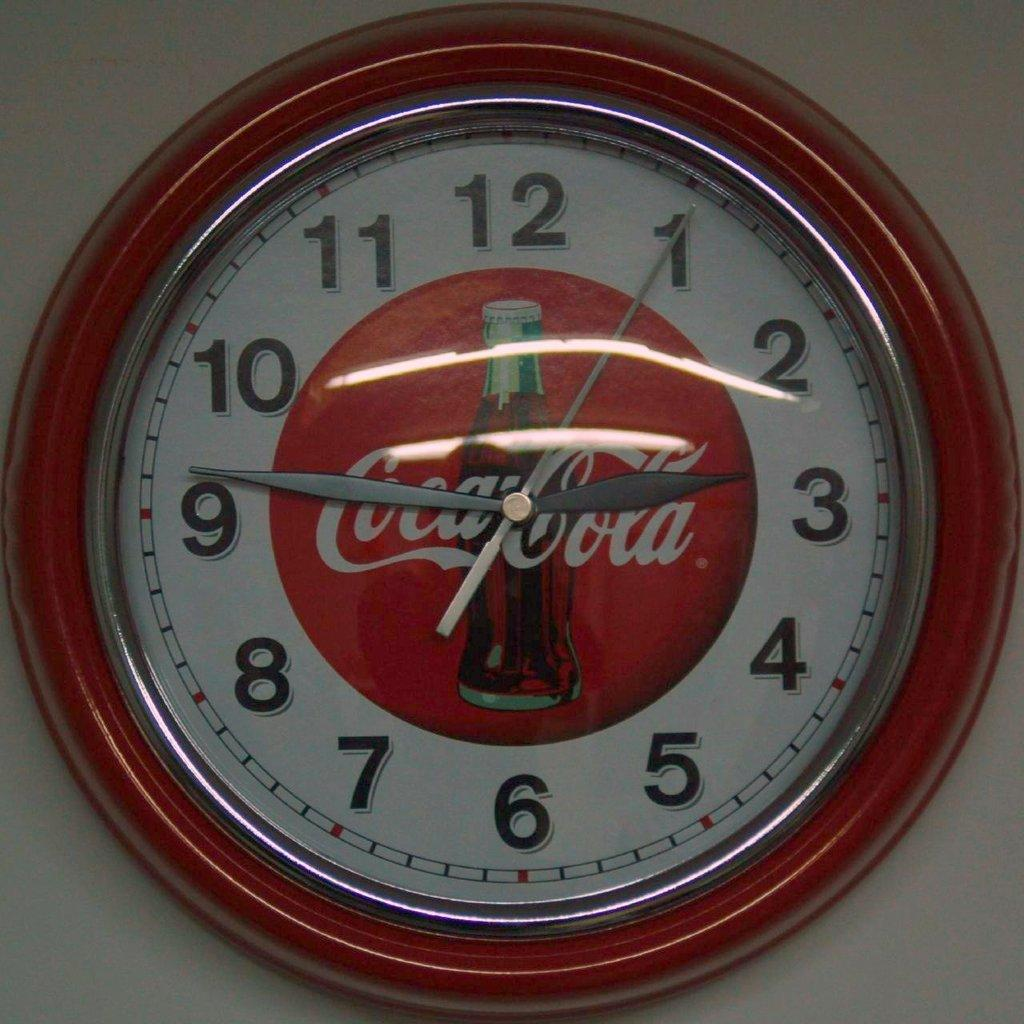<image>
Share a concise interpretation of the image provided. A Coca Cola clock hangs on the wall. 